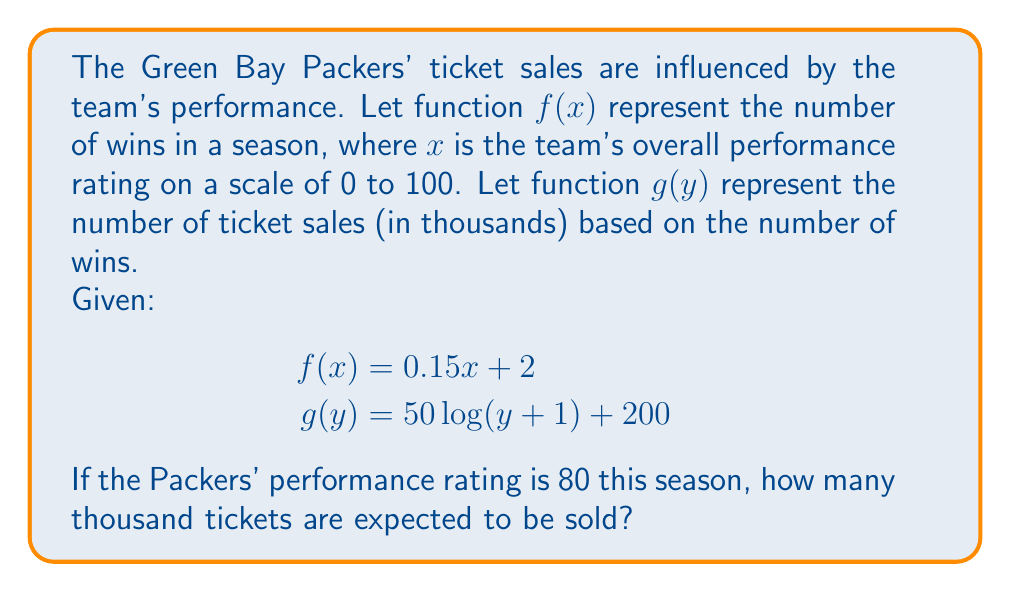Give your solution to this math problem. To solve this problem, we need to use function composition. We'll first find the number of wins based on the performance rating, then use that result to determine the ticket sales.

1. Calculate the number of wins using $f(x)$:
   $f(80) = 0.15(80) + 2 = 12 + 2 = 14$ wins

2. Now we use this result as the input for $g(y)$:
   $g(f(80)) = g(14)$

3. Calculate the ticket sales using $g(y)$:
   $g(14) = 50\log(14+1) + 200$
   $= 50\log(15) + 200$

4. Evaluate:
   $= 50(2.7081) + 200$ (using a calculator for $\log(15)$)
   $= 135.405 + 200$
   $= 335.405$

Therefore, approximately 335,405 tickets are expected to be sold.
Answer: 335.405 thousand tickets (or 335,405 tickets) 